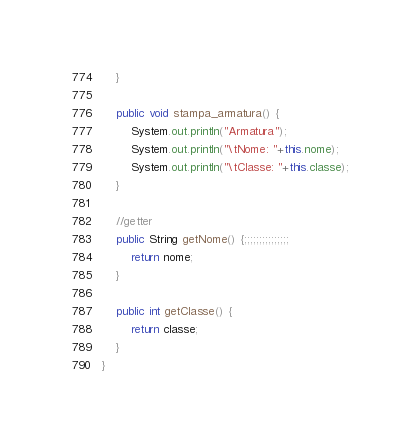<code> <loc_0><loc_0><loc_500><loc_500><_Java_>	}
	
	public void stampa_armatura() {
		System.out.println("Armatura");
		System.out.println("\tNome: "+this.nome);
		System.out.println("\tClasse: "+this.classe);
	}
	
	//getter 
	public String getNome() {;;;;;;;;;;;;;;;
		return nome;
	}

	public int getClasse() {
		return classe;
	}
}
</code> 